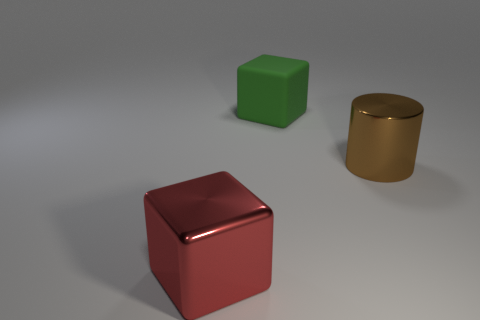The shiny object that is the same size as the brown cylinder is what color?
Offer a terse response. Red. There is a cube that is behind the brown object; what is its size?
Make the answer very short. Large. There is a metal thing in front of the big metal cylinder; are there any matte things on the right side of it?
Provide a short and direct response. Yes. Are the thing that is on the left side of the big rubber cube and the big green object made of the same material?
Provide a succinct answer. No. What number of objects are on the left side of the brown thing and in front of the large green matte block?
Give a very brief answer. 1. How many blocks are the same material as the big green object?
Your answer should be very brief. 0. There is a big block that is the same material as the brown object; what is its color?
Ensure brevity in your answer.  Red. Is the number of large shiny blocks less than the number of large yellow cylinders?
Ensure brevity in your answer.  No. There is a cube behind the large block in front of the metal thing that is behind the red thing; what is it made of?
Your response must be concise. Rubber. What is the material of the red thing?
Your answer should be compact. Metal. 